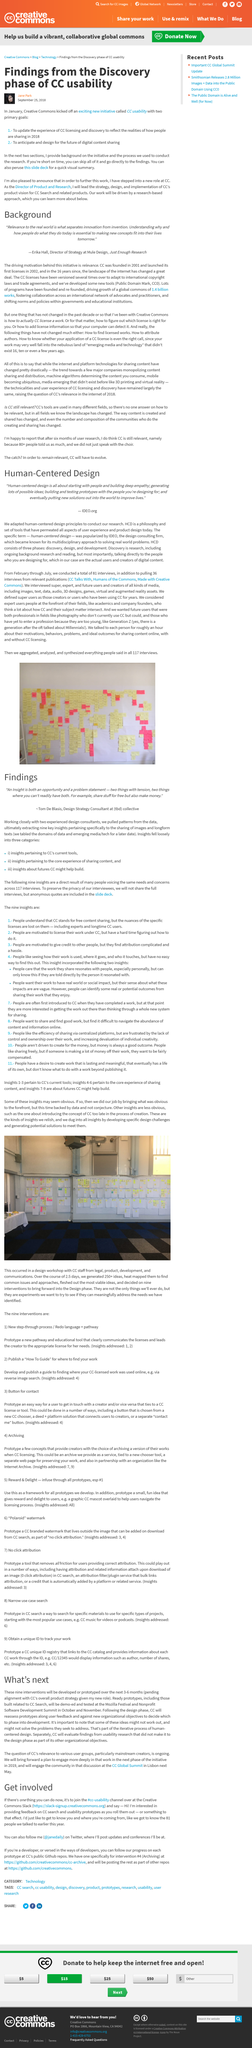Identify some key points in this picture. The project known as "CC usability" was initiated in January. Tom De Blasis is being quoted. Jane Park wrote the article titled "Findings from the Discovery phase of CC usability. The primary goal number 2 on the CC usability list is to anticipate and design for the future of digital content sharing. Erika Hall is employed by Just Enough Research. 